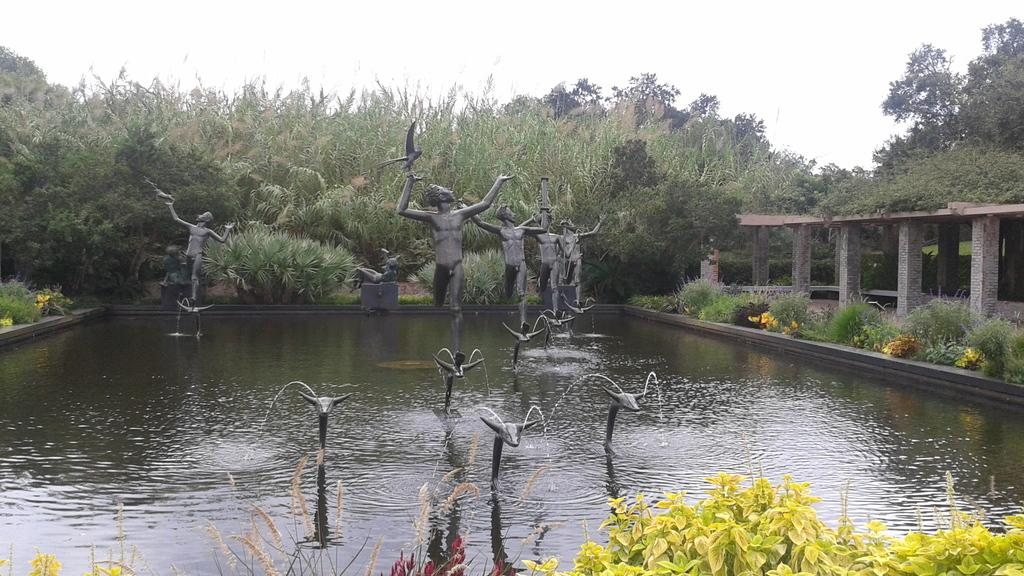What is the main feature in the image? There is a water fountain in the image. What other objects can be seen in the image? There are statues, plants, pillars, and trees in the image. What is visible in the background of the image? The sky is visible in the background of the image. What type of orange is hanging from the trees in the image? There are no oranges present in the image; the trees are not fruit-bearing trees. Can you see the moon in the image? The moon is not visible in the image; only the sky is visible in the background. 